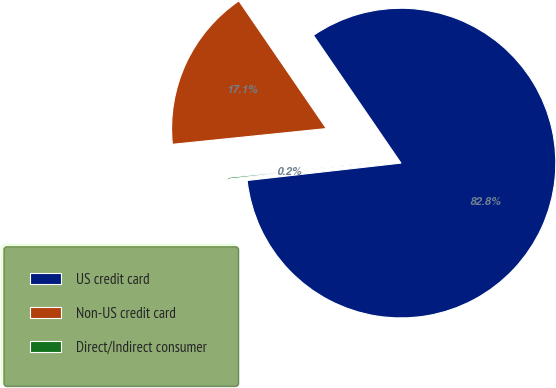Convert chart. <chart><loc_0><loc_0><loc_500><loc_500><pie_chart><fcel>US credit card<fcel>Non-US credit card<fcel>Direct/Indirect consumer<nl><fcel>82.76%<fcel>17.06%<fcel>0.17%<nl></chart> 